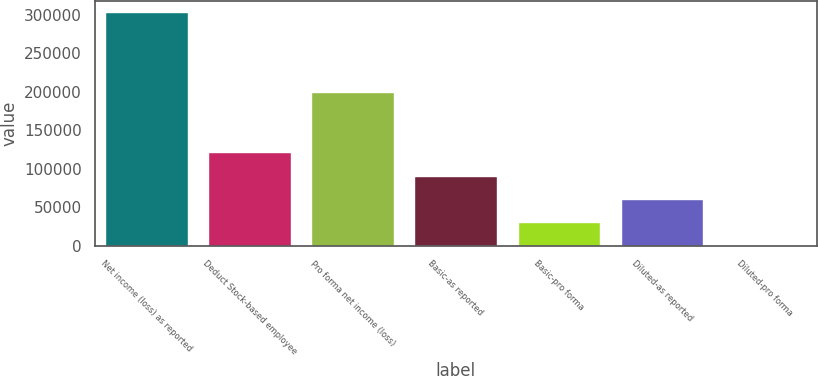Convert chart to OTSL. <chart><loc_0><loc_0><loc_500><loc_500><bar_chart><fcel>Net income (loss) as reported<fcel>Deduct Stock-based employee<fcel>Pro forma net income (loss)<fcel>Basic-as reported<fcel>Basic-pro forma<fcel>Diluted-as reported<fcel>Diluted-pro forma<nl><fcel>302989<fcel>121196<fcel>199914<fcel>90897.1<fcel>30299.4<fcel>60598.2<fcel>0.56<nl></chart> 